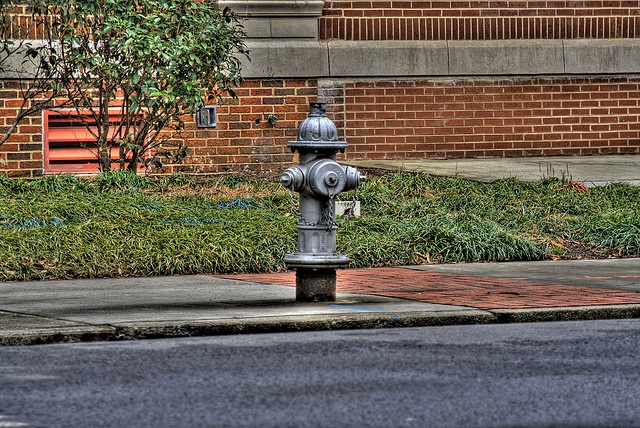Describe the objects in this image and their specific colors. I can see a fire hydrant in black, gray, darkgray, and lavender tones in this image. 